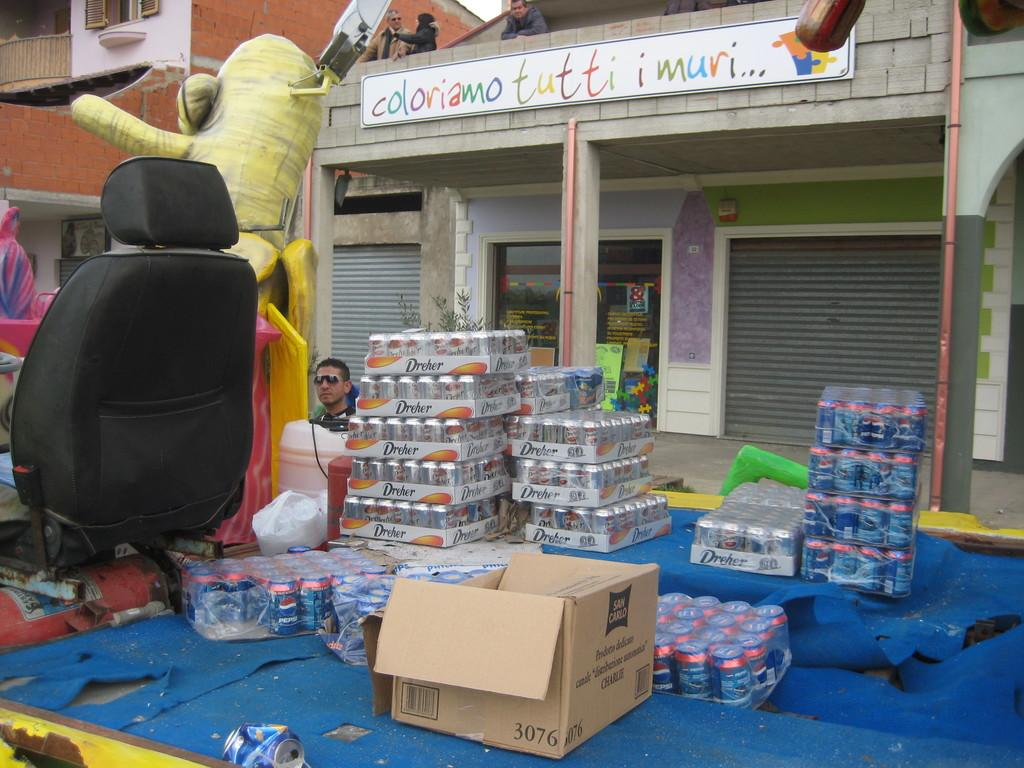Provide a one-sentence caption for the provided image. Cartons of sodas, including Pepsi, sit on the back of a truck. 